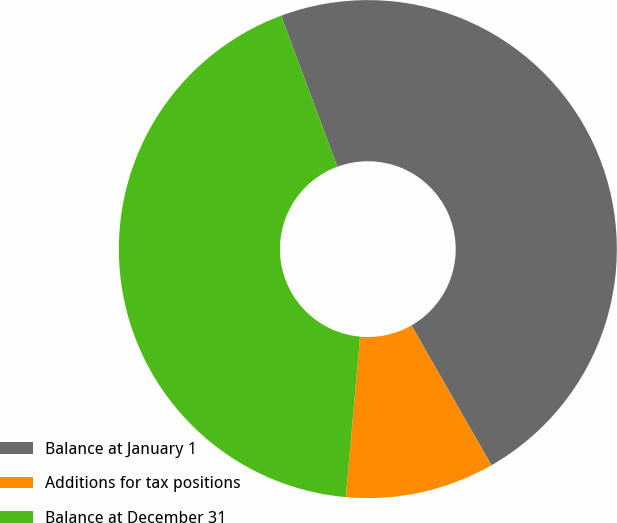<chart> <loc_0><loc_0><loc_500><loc_500><pie_chart><fcel>Balance at January 1<fcel>Additions for tax positions<fcel>Balance at December 31<nl><fcel>47.39%<fcel>9.68%<fcel>42.93%<nl></chart> 